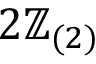<formula> <loc_0><loc_0><loc_500><loc_500>2 \mathbb { Z } _ { ( 2 ) }</formula> 